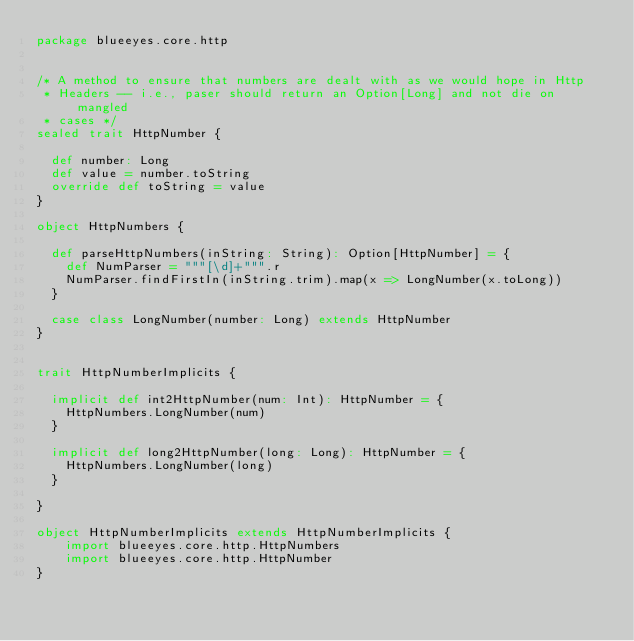Convert code to text. <code><loc_0><loc_0><loc_500><loc_500><_Scala_>package blueeyes.core.http


/* A method to ensure that numbers are dealt with as we would hope in Http
 * Headers -- i.e., paser should return an Option[Long] and not die on mangled
 * cases */
sealed trait HttpNumber {

  def number: Long
  def value = number.toString
  override def toString = value
}

object HttpNumbers {

  def parseHttpNumbers(inString: String): Option[HttpNumber] = {
    def NumParser = """[\d]+""".r
    NumParser.findFirstIn(inString.trim).map(x => LongNumber(x.toLong))
  }

  case class LongNumber(number: Long) extends HttpNumber
}


trait HttpNumberImplicits { 
  
  implicit def int2HttpNumber(num: Int): HttpNumber = {
    HttpNumbers.LongNumber(num)
  }

  implicit def long2HttpNumber(long: Long): HttpNumber = {
    HttpNumbers.LongNumber(long)
  }

}

object HttpNumberImplicits extends HttpNumberImplicits {
    import blueeyes.core.http.HttpNumbers
    import blueeyes.core.http.HttpNumber
}





</code> 